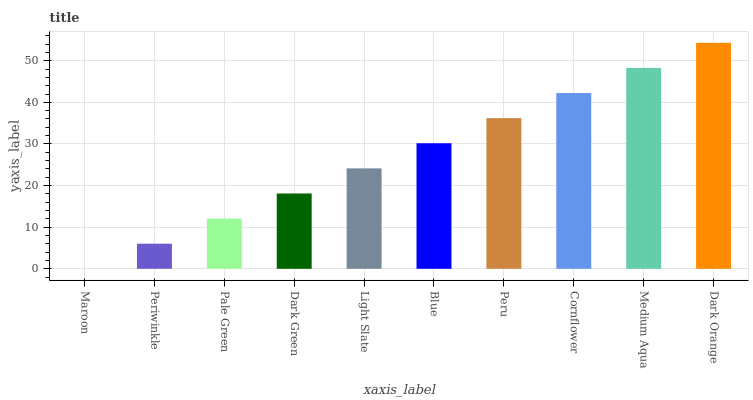Is Maroon the minimum?
Answer yes or no. Yes. Is Dark Orange the maximum?
Answer yes or no. Yes. Is Periwinkle the minimum?
Answer yes or no. No. Is Periwinkle the maximum?
Answer yes or no. No. Is Periwinkle greater than Maroon?
Answer yes or no. Yes. Is Maroon less than Periwinkle?
Answer yes or no. Yes. Is Maroon greater than Periwinkle?
Answer yes or no. No. Is Periwinkle less than Maroon?
Answer yes or no. No. Is Blue the high median?
Answer yes or no. Yes. Is Light Slate the low median?
Answer yes or no. Yes. Is Periwinkle the high median?
Answer yes or no. No. Is Periwinkle the low median?
Answer yes or no. No. 